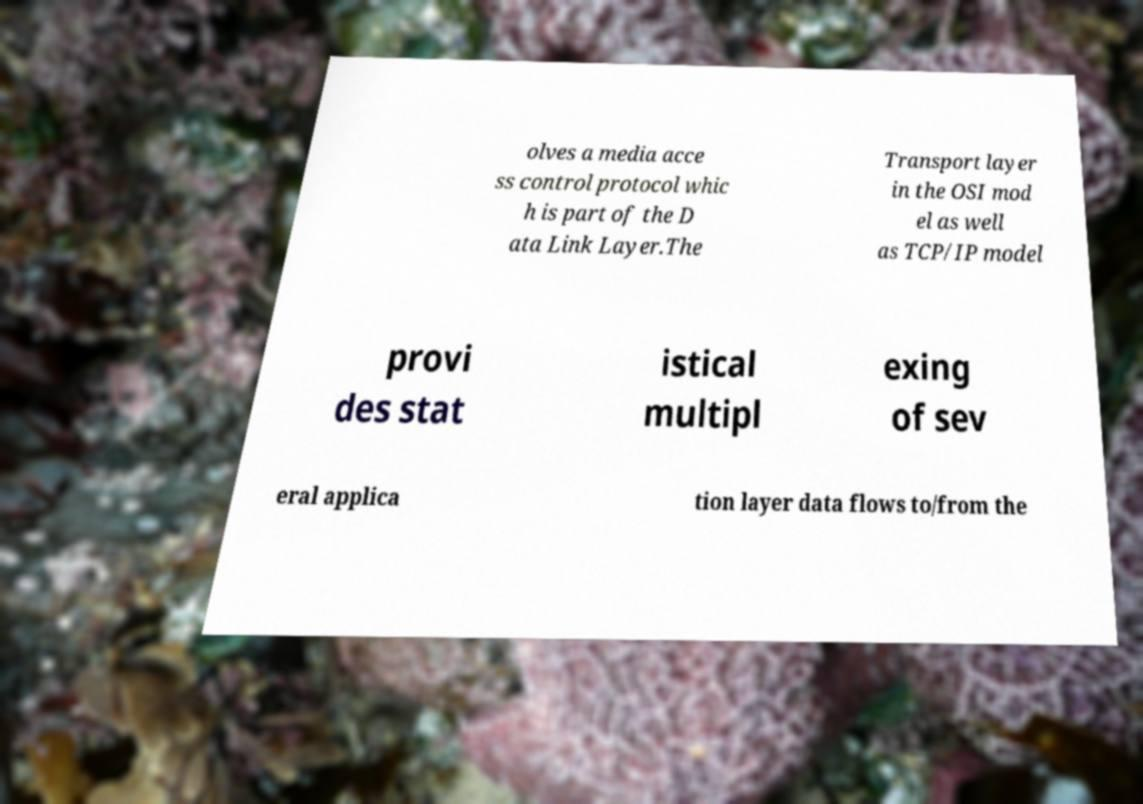Could you assist in decoding the text presented in this image and type it out clearly? olves a media acce ss control protocol whic h is part of the D ata Link Layer.The Transport layer in the OSI mod el as well as TCP/IP model provi des stat istical multipl exing of sev eral applica tion layer data flows to/from the 